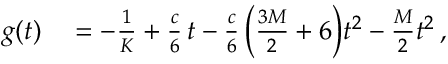<formula> <loc_0><loc_0><loc_500><loc_500>\begin{array} { r l } { g ( t ) } & = - \frac { 1 } { K } + \frac { c } { 6 } \, t - \frac { c } { 6 } \, \left ( \frac { 3 M } { 2 } + 6 \right ) t ^ { 2 } - \frac { M } { 2 } t ^ { 2 } \, , } \end{array}</formula> 